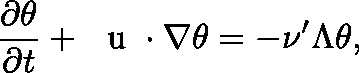Convert formula to latex. <formula><loc_0><loc_0><loc_500><loc_500>\frac { \partial \theta } { \partial t } + \boldmath u \cdot \nabla \theta = - \nu ^ { \prime } \Lambda \theta ,</formula> 